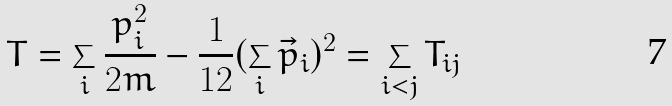Convert formula to latex. <formula><loc_0><loc_0><loc_500><loc_500>T = \sum _ { i } \frac { p _ { i } ^ { 2 } } { 2 m } - \frac { 1 } { 1 2 } ( \sum _ { i } \vec { p } _ { i } ) ^ { 2 } = \sum _ { i < j } T _ { i j }</formula> 